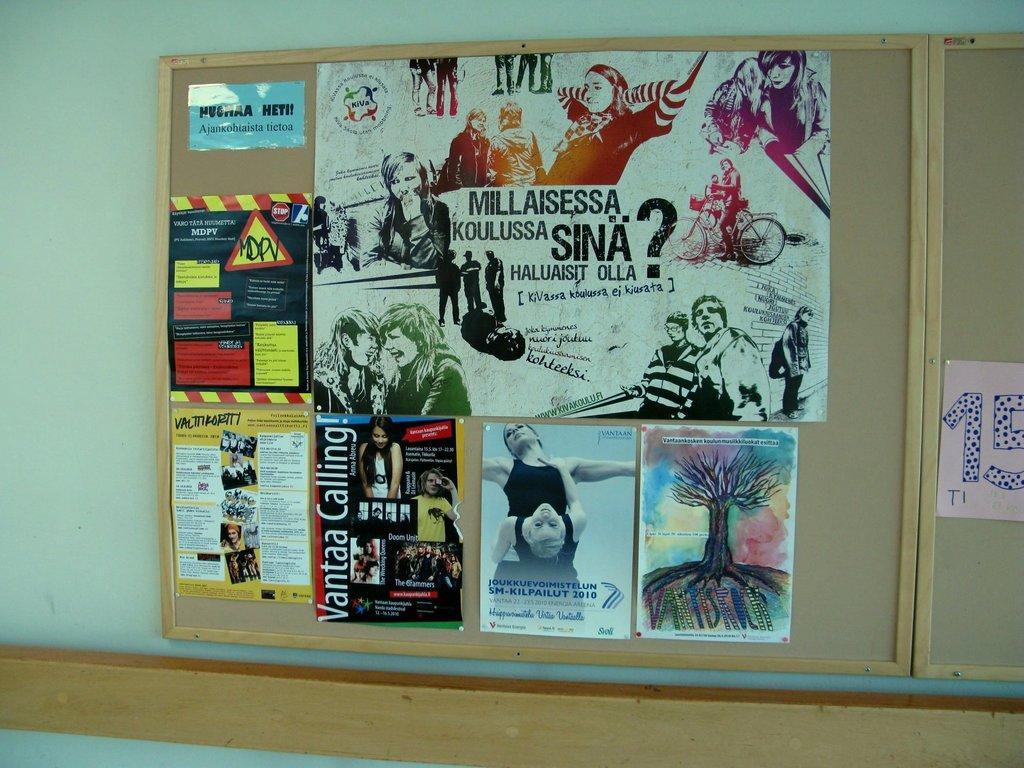Please provide a concise description of this image. In the image there are photographs and pamphlets on wooden board on a wall. 